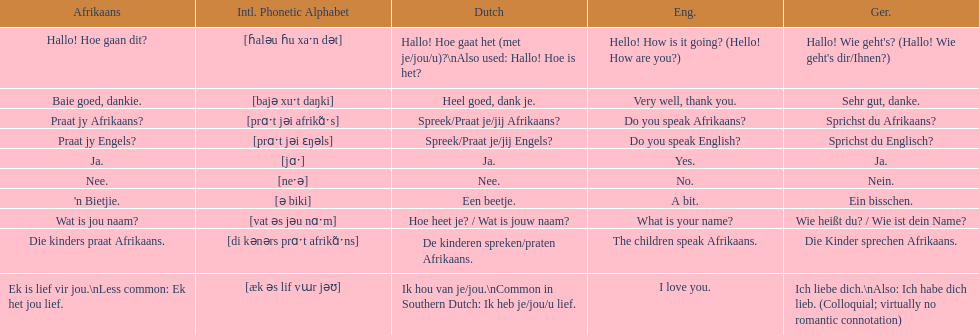How do you utter 'yes' in afrikaans? Ja. 